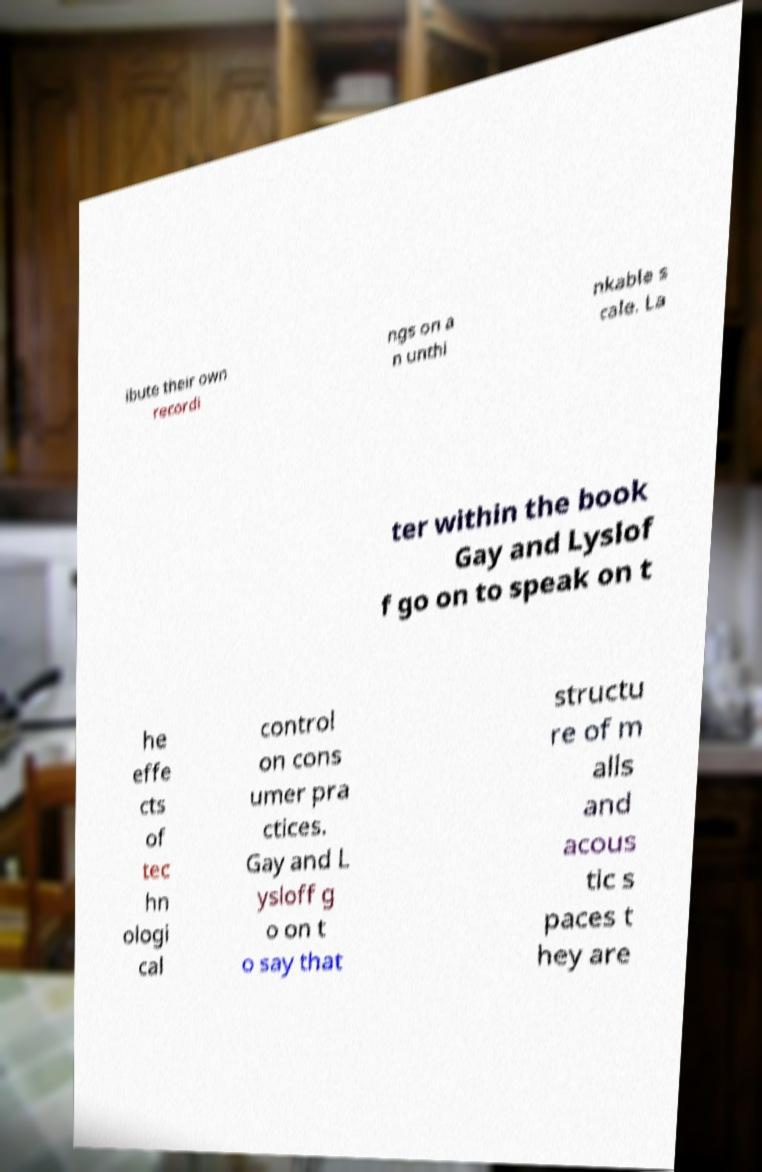Could you extract and type out the text from this image? ibute their own recordi ngs on a n unthi nkable s cale. La ter within the book Gay and Lyslof f go on to speak on t he effe cts of tec hn ologi cal control on cons umer pra ctices. Gay and L ysloff g o on t o say that structu re of m alls and acous tic s paces t hey are 